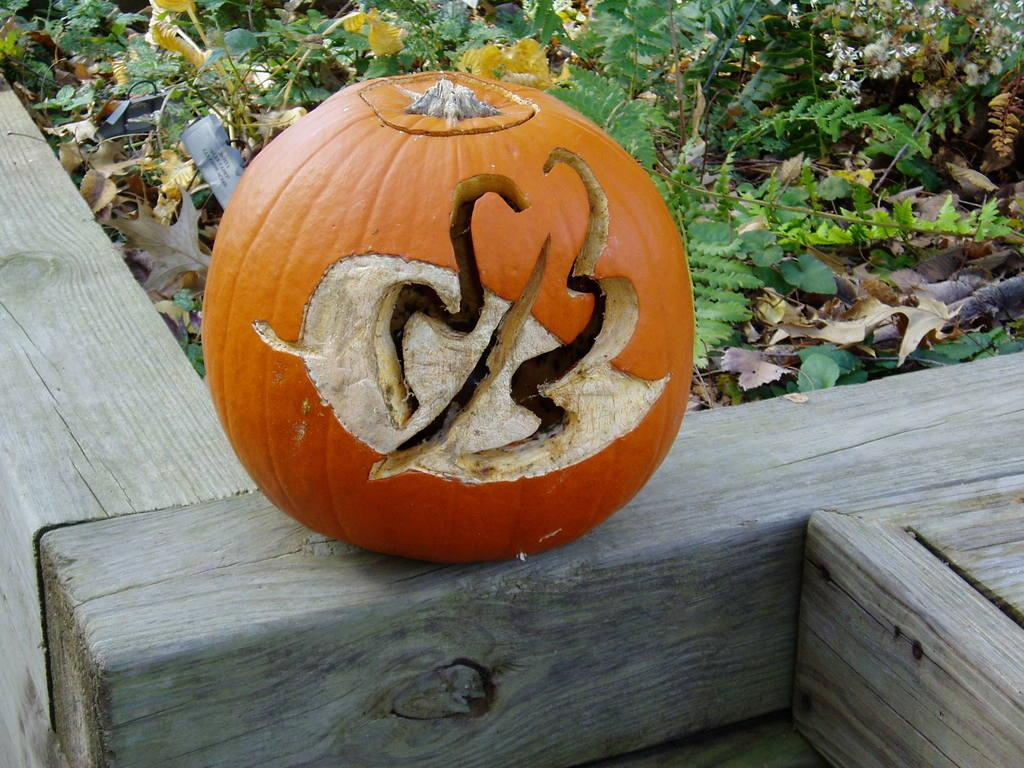What is the main object in the image? There is a pumpkin on a wooden stick in the image. What can be seen in the background of the image? Plants and dried leaves are visible in the background of the image. What does the grandfather say about the cave in the image? There is no mention of a cave or a grandfather in the image, so this question cannot be answered. 